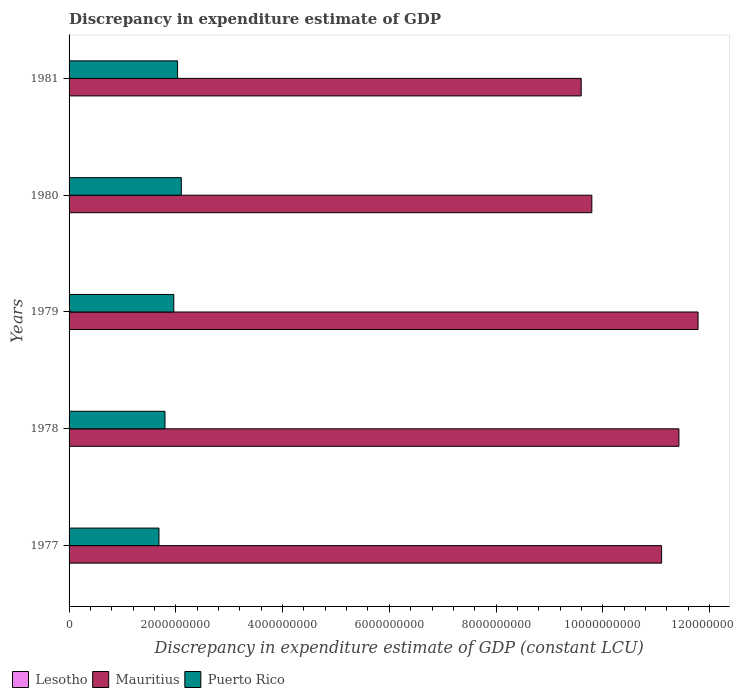Are the number of bars per tick equal to the number of legend labels?
Your answer should be very brief. No. How many bars are there on the 2nd tick from the top?
Offer a very short reply. 2. What is the label of the 4th group of bars from the top?
Your answer should be very brief. 1978. What is the discrepancy in expenditure estimate of GDP in Lesotho in 1980?
Ensure brevity in your answer.  0. Across all years, what is the maximum discrepancy in expenditure estimate of GDP in Mauritius?
Keep it short and to the point. 1.18e+1. Across all years, what is the minimum discrepancy in expenditure estimate of GDP in Lesotho?
Ensure brevity in your answer.  0. In which year was the discrepancy in expenditure estimate of GDP in Mauritius maximum?
Your answer should be very brief. 1979. What is the total discrepancy in expenditure estimate of GDP in Lesotho in the graph?
Offer a terse response. 0. What is the difference between the discrepancy in expenditure estimate of GDP in Mauritius in 1978 and that in 1981?
Your answer should be compact. 1.83e+09. What is the difference between the discrepancy in expenditure estimate of GDP in Lesotho in 1981 and the discrepancy in expenditure estimate of GDP in Puerto Rico in 1980?
Provide a short and direct response. -2.10e+09. What is the average discrepancy in expenditure estimate of GDP in Puerto Rico per year?
Your response must be concise. 1.92e+09. In the year 1979, what is the difference between the discrepancy in expenditure estimate of GDP in Mauritius and discrepancy in expenditure estimate of GDP in Puerto Rico?
Your response must be concise. 9.82e+09. What is the ratio of the discrepancy in expenditure estimate of GDP in Mauritius in 1978 to that in 1980?
Make the answer very short. 1.17. Is the difference between the discrepancy in expenditure estimate of GDP in Mauritius in 1979 and 1980 greater than the difference between the discrepancy in expenditure estimate of GDP in Puerto Rico in 1979 and 1980?
Give a very brief answer. Yes. What is the difference between the highest and the second highest discrepancy in expenditure estimate of GDP in Puerto Rico?
Keep it short and to the point. 6.97e+07. What is the difference between the highest and the lowest discrepancy in expenditure estimate of GDP in Puerto Rico?
Your answer should be compact. 4.18e+08. Is it the case that in every year, the sum of the discrepancy in expenditure estimate of GDP in Lesotho and discrepancy in expenditure estimate of GDP in Mauritius is greater than the discrepancy in expenditure estimate of GDP in Puerto Rico?
Offer a terse response. Yes. How many bars are there?
Make the answer very short. 10. Are all the bars in the graph horizontal?
Your answer should be very brief. Yes. How many years are there in the graph?
Provide a succinct answer. 5. Does the graph contain grids?
Keep it short and to the point. No. Where does the legend appear in the graph?
Make the answer very short. Bottom left. What is the title of the graph?
Ensure brevity in your answer.  Discrepancy in expenditure estimate of GDP. What is the label or title of the X-axis?
Your response must be concise. Discrepancy in expenditure estimate of GDP (constant LCU). What is the Discrepancy in expenditure estimate of GDP (constant LCU) in Mauritius in 1977?
Make the answer very short. 1.11e+1. What is the Discrepancy in expenditure estimate of GDP (constant LCU) of Puerto Rico in 1977?
Ensure brevity in your answer.  1.68e+09. What is the Discrepancy in expenditure estimate of GDP (constant LCU) of Mauritius in 1978?
Keep it short and to the point. 1.14e+1. What is the Discrepancy in expenditure estimate of GDP (constant LCU) of Puerto Rico in 1978?
Ensure brevity in your answer.  1.80e+09. What is the Discrepancy in expenditure estimate of GDP (constant LCU) in Lesotho in 1979?
Your answer should be compact. 0. What is the Discrepancy in expenditure estimate of GDP (constant LCU) of Mauritius in 1979?
Your answer should be compact. 1.18e+1. What is the Discrepancy in expenditure estimate of GDP (constant LCU) of Puerto Rico in 1979?
Your response must be concise. 1.96e+09. What is the Discrepancy in expenditure estimate of GDP (constant LCU) of Mauritius in 1980?
Make the answer very short. 9.79e+09. What is the Discrepancy in expenditure estimate of GDP (constant LCU) of Puerto Rico in 1980?
Your answer should be very brief. 2.10e+09. What is the Discrepancy in expenditure estimate of GDP (constant LCU) in Lesotho in 1981?
Your answer should be very brief. 0. What is the Discrepancy in expenditure estimate of GDP (constant LCU) of Mauritius in 1981?
Keep it short and to the point. 9.60e+09. What is the Discrepancy in expenditure estimate of GDP (constant LCU) in Puerto Rico in 1981?
Make the answer very short. 2.03e+09. Across all years, what is the maximum Discrepancy in expenditure estimate of GDP (constant LCU) of Mauritius?
Keep it short and to the point. 1.18e+1. Across all years, what is the maximum Discrepancy in expenditure estimate of GDP (constant LCU) in Puerto Rico?
Give a very brief answer. 2.10e+09. Across all years, what is the minimum Discrepancy in expenditure estimate of GDP (constant LCU) of Mauritius?
Give a very brief answer. 9.60e+09. Across all years, what is the minimum Discrepancy in expenditure estimate of GDP (constant LCU) of Puerto Rico?
Your response must be concise. 1.68e+09. What is the total Discrepancy in expenditure estimate of GDP (constant LCU) in Mauritius in the graph?
Provide a short and direct response. 5.37e+1. What is the total Discrepancy in expenditure estimate of GDP (constant LCU) of Puerto Rico in the graph?
Keep it short and to the point. 9.58e+09. What is the difference between the Discrepancy in expenditure estimate of GDP (constant LCU) in Mauritius in 1977 and that in 1978?
Your answer should be very brief. -3.24e+08. What is the difference between the Discrepancy in expenditure estimate of GDP (constant LCU) of Puerto Rico in 1977 and that in 1978?
Provide a succinct answer. -1.13e+08. What is the difference between the Discrepancy in expenditure estimate of GDP (constant LCU) in Mauritius in 1977 and that in 1979?
Your answer should be compact. -6.83e+08. What is the difference between the Discrepancy in expenditure estimate of GDP (constant LCU) in Puerto Rico in 1977 and that in 1979?
Your answer should be very brief. -2.77e+08. What is the difference between the Discrepancy in expenditure estimate of GDP (constant LCU) of Mauritius in 1977 and that in 1980?
Keep it short and to the point. 1.31e+09. What is the difference between the Discrepancy in expenditure estimate of GDP (constant LCU) of Puerto Rico in 1977 and that in 1980?
Ensure brevity in your answer.  -4.18e+08. What is the difference between the Discrepancy in expenditure estimate of GDP (constant LCU) of Mauritius in 1977 and that in 1981?
Your response must be concise. 1.51e+09. What is the difference between the Discrepancy in expenditure estimate of GDP (constant LCU) in Puerto Rico in 1977 and that in 1981?
Offer a very short reply. -3.49e+08. What is the difference between the Discrepancy in expenditure estimate of GDP (constant LCU) of Mauritius in 1978 and that in 1979?
Ensure brevity in your answer.  -3.58e+08. What is the difference between the Discrepancy in expenditure estimate of GDP (constant LCU) in Puerto Rico in 1978 and that in 1979?
Provide a short and direct response. -1.65e+08. What is the difference between the Discrepancy in expenditure estimate of GDP (constant LCU) of Mauritius in 1978 and that in 1980?
Your response must be concise. 1.63e+09. What is the difference between the Discrepancy in expenditure estimate of GDP (constant LCU) in Puerto Rico in 1978 and that in 1980?
Your response must be concise. -3.06e+08. What is the difference between the Discrepancy in expenditure estimate of GDP (constant LCU) in Mauritius in 1978 and that in 1981?
Provide a succinct answer. 1.83e+09. What is the difference between the Discrepancy in expenditure estimate of GDP (constant LCU) in Puerto Rico in 1978 and that in 1981?
Your response must be concise. -2.36e+08. What is the difference between the Discrepancy in expenditure estimate of GDP (constant LCU) in Mauritius in 1979 and that in 1980?
Ensure brevity in your answer.  1.99e+09. What is the difference between the Discrepancy in expenditure estimate of GDP (constant LCU) in Puerto Rico in 1979 and that in 1980?
Make the answer very short. -1.41e+08. What is the difference between the Discrepancy in expenditure estimate of GDP (constant LCU) in Mauritius in 1979 and that in 1981?
Keep it short and to the point. 2.19e+09. What is the difference between the Discrepancy in expenditure estimate of GDP (constant LCU) in Puerto Rico in 1979 and that in 1981?
Your response must be concise. -7.12e+07. What is the difference between the Discrepancy in expenditure estimate of GDP (constant LCU) of Mauritius in 1980 and that in 1981?
Give a very brief answer. 1.99e+08. What is the difference between the Discrepancy in expenditure estimate of GDP (constant LCU) in Puerto Rico in 1980 and that in 1981?
Your answer should be very brief. 6.97e+07. What is the difference between the Discrepancy in expenditure estimate of GDP (constant LCU) in Mauritius in 1977 and the Discrepancy in expenditure estimate of GDP (constant LCU) in Puerto Rico in 1978?
Provide a succinct answer. 9.30e+09. What is the difference between the Discrepancy in expenditure estimate of GDP (constant LCU) in Mauritius in 1977 and the Discrepancy in expenditure estimate of GDP (constant LCU) in Puerto Rico in 1979?
Provide a short and direct response. 9.14e+09. What is the difference between the Discrepancy in expenditure estimate of GDP (constant LCU) in Mauritius in 1977 and the Discrepancy in expenditure estimate of GDP (constant LCU) in Puerto Rico in 1980?
Your answer should be compact. 9.00e+09. What is the difference between the Discrepancy in expenditure estimate of GDP (constant LCU) of Mauritius in 1977 and the Discrepancy in expenditure estimate of GDP (constant LCU) of Puerto Rico in 1981?
Your response must be concise. 9.07e+09. What is the difference between the Discrepancy in expenditure estimate of GDP (constant LCU) of Mauritius in 1978 and the Discrepancy in expenditure estimate of GDP (constant LCU) of Puerto Rico in 1979?
Your answer should be very brief. 9.46e+09. What is the difference between the Discrepancy in expenditure estimate of GDP (constant LCU) in Mauritius in 1978 and the Discrepancy in expenditure estimate of GDP (constant LCU) in Puerto Rico in 1980?
Provide a short and direct response. 9.32e+09. What is the difference between the Discrepancy in expenditure estimate of GDP (constant LCU) in Mauritius in 1978 and the Discrepancy in expenditure estimate of GDP (constant LCU) in Puerto Rico in 1981?
Give a very brief answer. 9.39e+09. What is the difference between the Discrepancy in expenditure estimate of GDP (constant LCU) of Mauritius in 1979 and the Discrepancy in expenditure estimate of GDP (constant LCU) of Puerto Rico in 1980?
Provide a succinct answer. 9.68e+09. What is the difference between the Discrepancy in expenditure estimate of GDP (constant LCU) in Mauritius in 1979 and the Discrepancy in expenditure estimate of GDP (constant LCU) in Puerto Rico in 1981?
Offer a terse response. 9.75e+09. What is the difference between the Discrepancy in expenditure estimate of GDP (constant LCU) in Mauritius in 1980 and the Discrepancy in expenditure estimate of GDP (constant LCU) in Puerto Rico in 1981?
Offer a terse response. 7.76e+09. What is the average Discrepancy in expenditure estimate of GDP (constant LCU) of Mauritius per year?
Your answer should be compact. 1.07e+1. What is the average Discrepancy in expenditure estimate of GDP (constant LCU) in Puerto Rico per year?
Offer a terse response. 1.92e+09. In the year 1977, what is the difference between the Discrepancy in expenditure estimate of GDP (constant LCU) of Mauritius and Discrepancy in expenditure estimate of GDP (constant LCU) of Puerto Rico?
Offer a very short reply. 9.42e+09. In the year 1978, what is the difference between the Discrepancy in expenditure estimate of GDP (constant LCU) in Mauritius and Discrepancy in expenditure estimate of GDP (constant LCU) in Puerto Rico?
Your answer should be very brief. 9.63e+09. In the year 1979, what is the difference between the Discrepancy in expenditure estimate of GDP (constant LCU) of Mauritius and Discrepancy in expenditure estimate of GDP (constant LCU) of Puerto Rico?
Your answer should be compact. 9.82e+09. In the year 1980, what is the difference between the Discrepancy in expenditure estimate of GDP (constant LCU) of Mauritius and Discrepancy in expenditure estimate of GDP (constant LCU) of Puerto Rico?
Provide a short and direct response. 7.69e+09. In the year 1981, what is the difference between the Discrepancy in expenditure estimate of GDP (constant LCU) in Mauritius and Discrepancy in expenditure estimate of GDP (constant LCU) in Puerto Rico?
Make the answer very short. 7.56e+09. What is the ratio of the Discrepancy in expenditure estimate of GDP (constant LCU) of Mauritius in 1977 to that in 1978?
Your answer should be very brief. 0.97. What is the ratio of the Discrepancy in expenditure estimate of GDP (constant LCU) in Puerto Rico in 1977 to that in 1978?
Make the answer very short. 0.94. What is the ratio of the Discrepancy in expenditure estimate of GDP (constant LCU) of Mauritius in 1977 to that in 1979?
Your answer should be compact. 0.94. What is the ratio of the Discrepancy in expenditure estimate of GDP (constant LCU) in Puerto Rico in 1977 to that in 1979?
Your answer should be very brief. 0.86. What is the ratio of the Discrepancy in expenditure estimate of GDP (constant LCU) of Mauritius in 1977 to that in 1980?
Provide a succinct answer. 1.13. What is the ratio of the Discrepancy in expenditure estimate of GDP (constant LCU) in Puerto Rico in 1977 to that in 1980?
Your answer should be very brief. 0.8. What is the ratio of the Discrepancy in expenditure estimate of GDP (constant LCU) in Mauritius in 1977 to that in 1981?
Your answer should be compact. 1.16. What is the ratio of the Discrepancy in expenditure estimate of GDP (constant LCU) of Puerto Rico in 1977 to that in 1981?
Your answer should be very brief. 0.83. What is the ratio of the Discrepancy in expenditure estimate of GDP (constant LCU) of Mauritius in 1978 to that in 1979?
Your answer should be compact. 0.97. What is the ratio of the Discrepancy in expenditure estimate of GDP (constant LCU) of Puerto Rico in 1978 to that in 1979?
Give a very brief answer. 0.92. What is the ratio of the Discrepancy in expenditure estimate of GDP (constant LCU) of Mauritius in 1978 to that in 1980?
Your answer should be very brief. 1.17. What is the ratio of the Discrepancy in expenditure estimate of GDP (constant LCU) of Puerto Rico in 1978 to that in 1980?
Provide a short and direct response. 0.85. What is the ratio of the Discrepancy in expenditure estimate of GDP (constant LCU) in Mauritius in 1978 to that in 1981?
Make the answer very short. 1.19. What is the ratio of the Discrepancy in expenditure estimate of GDP (constant LCU) in Puerto Rico in 1978 to that in 1981?
Ensure brevity in your answer.  0.88. What is the ratio of the Discrepancy in expenditure estimate of GDP (constant LCU) of Mauritius in 1979 to that in 1980?
Provide a short and direct response. 1.2. What is the ratio of the Discrepancy in expenditure estimate of GDP (constant LCU) in Puerto Rico in 1979 to that in 1980?
Offer a very short reply. 0.93. What is the ratio of the Discrepancy in expenditure estimate of GDP (constant LCU) in Mauritius in 1979 to that in 1981?
Offer a very short reply. 1.23. What is the ratio of the Discrepancy in expenditure estimate of GDP (constant LCU) of Puerto Rico in 1979 to that in 1981?
Your answer should be very brief. 0.96. What is the ratio of the Discrepancy in expenditure estimate of GDP (constant LCU) of Mauritius in 1980 to that in 1981?
Ensure brevity in your answer.  1.02. What is the ratio of the Discrepancy in expenditure estimate of GDP (constant LCU) of Puerto Rico in 1980 to that in 1981?
Ensure brevity in your answer.  1.03. What is the difference between the highest and the second highest Discrepancy in expenditure estimate of GDP (constant LCU) of Mauritius?
Your response must be concise. 3.58e+08. What is the difference between the highest and the second highest Discrepancy in expenditure estimate of GDP (constant LCU) of Puerto Rico?
Your response must be concise. 6.97e+07. What is the difference between the highest and the lowest Discrepancy in expenditure estimate of GDP (constant LCU) of Mauritius?
Provide a succinct answer. 2.19e+09. What is the difference between the highest and the lowest Discrepancy in expenditure estimate of GDP (constant LCU) of Puerto Rico?
Provide a succinct answer. 4.18e+08. 